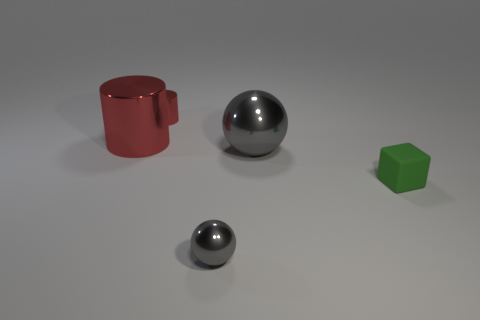There is a metallic object in front of the sphere that is behind the green thing; what shape is it?
Give a very brief answer. Sphere. Is there any other thing that has the same color as the small rubber object?
Your response must be concise. No. Is there anything else that is the same size as the block?
Offer a very short reply. Yes. What number of things are big red cylinders or tiny metallic spheres?
Provide a short and direct response. 2. Are there any metallic cylinders that have the same size as the matte thing?
Your answer should be compact. Yes. What is the shape of the small red metal thing?
Offer a terse response. Cylinder. Are there more red shiny cylinders that are right of the large gray thing than tiny gray metallic things that are behind the tiny red cylinder?
Offer a terse response. No. Do the big shiny thing that is on the right side of the big red metallic cylinder and the tiny shiny thing behind the matte cube have the same color?
Your answer should be very brief. No. There is a red shiny object that is the same size as the green rubber thing; what is its shape?
Ensure brevity in your answer.  Cylinder. Are there any other red objects of the same shape as the matte object?
Provide a short and direct response. No. 